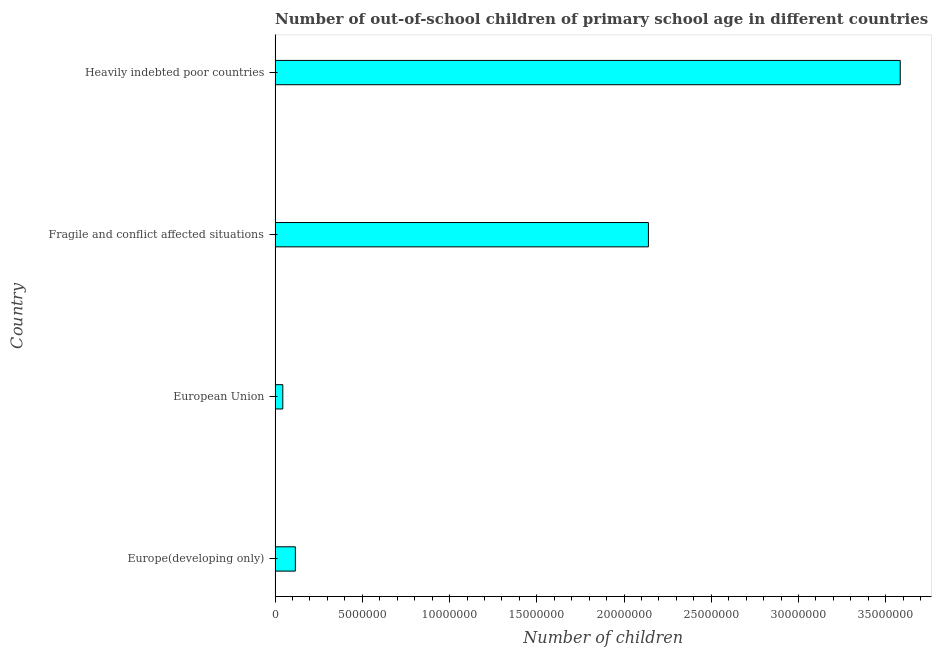Does the graph contain any zero values?
Your answer should be very brief. No. Does the graph contain grids?
Your answer should be very brief. No. What is the title of the graph?
Provide a short and direct response. Number of out-of-school children of primary school age in different countries. What is the label or title of the X-axis?
Keep it short and to the point. Number of children. What is the number of out-of-school children in European Union?
Provide a short and direct response. 4.43e+05. Across all countries, what is the maximum number of out-of-school children?
Ensure brevity in your answer.  3.58e+07. Across all countries, what is the minimum number of out-of-school children?
Offer a terse response. 4.43e+05. In which country was the number of out-of-school children maximum?
Provide a succinct answer. Heavily indebted poor countries. In which country was the number of out-of-school children minimum?
Your answer should be very brief. European Union. What is the sum of the number of out-of-school children?
Provide a succinct answer. 5.88e+07. What is the difference between the number of out-of-school children in European Union and Fragile and conflict affected situations?
Your response must be concise. -2.10e+07. What is the average number of out-of-school children per country?
Provide a succinct answer. 1.47e+07. What is the median number of out-of-school children?
Your response must be concise. 1.13e+07. What is the ratio of the number of out-of-school children in Europe(developing only) to that in European Union?
Keep it short and to the point. 2.62. What is the difference between the highest and the second highest number of out-of-school children?
Give a very brief answer. 1.44e+07. What is the difference between the highest and the lowest number of out-of-school children?
Provide a short and direct response. 3.54e+07. In how many countries, is the number of out-of-school children greater than the average number of out-of-school children taken over all countries?
Make the answer very short. 2. How many bars are there?
Your answer should be very brief. 4. How many countries are there in the graph?
Provide a succinct answer. 4. What is the difference between two consecutive major ticks on the X-axis?
Ensure brevity in your answer.  5.00e+06. Are the values on the major ticks of X-axis written in scientific E-notation?
Offer a very short reply. No. What is the Number of children of Europe(developing only)?
Make the answer very short. 1.16e+06. What is the Number of children in European Union?
Your answer should be very brief. 4.43e+05. What is the Number of children in Fragile and conflict affected situations?
Provide a short and direct response. 2.14e+07. What is the Number of children in Heavily indebted poor countries?
Offer a very short reply. 3.58e+07. What is the difference between the Number of children in Europe(developing only) and European Union?
Offer a very short reply. 7.18e+05. What is the difference between the Number of children in Europe(developing only) and Fragile and conflict affected situations?
Your response must be concise. -2.02e+07. What is the difference between the Number of children in Europe(developing only) and Heavily indebted poor countries?
Your response must be concise. -3.47e+07. What is the difference between the Number of children in European Union and Fragile and conflict affected situations?
Provide a short and direct response. -2.10e+07. What is the difference between the Number of children in European Union and Heavily indebted poor countries?
Your response must be concise. -3.54e+07. What is the difference between the Number of children in Fragile and conflict affected situations and Heavily indebted poor countries?
Offer a terse response. -1.44e+07. What is the ratio of the Number of children in Europe(developing only) to that in European Union?
Offer a terse response. 2.62. What is the ratio of the Number of children in Europe(developing only) to that in Fragile and conflict affected situations?
Your response must be concise. 0.05. What is the ratio of the Number of children in Europe(developing only) to that in Heavily indebted poor countries?
Make the answer very short. 0.03. What is the ratio of the Number of children in European Union to that in Fragile and conflict affected situations?
Ensure brevity in your answer.  0.02. What is the ratio of the Number of children in European Union to that in Heavily indebted poor countries?
Provide a short and direct response. 0.01. What is the ratio of the Number of children in Fragile and conflict affected situations to that in Heavily indebted poor countries?
Give a very brief answer. 0.6. 